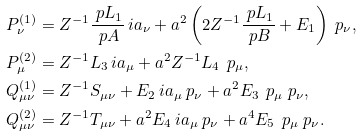Convert formula to latex. <formula><loc_0><loc_0><loc_500><loc_500>P ^ { ( 1 ) } _ { \nu } & = Z ^ { - 1 } \frac { \ p L _ { 1 } } { \ p A } \, i a _ { \nu } + a ^ { 2 } \left ( 2 Z ^ { - 1 } \frac { \ p L _ { 1 } } { \ p B } + E _ { 1 } \right ) \ p _ { \nu } , \\ P ^ { ( 2 ) } _ { \mu } & = Z ^ { - 1 } L _ { 3 } \, i a _ { \mu } + a ^ { 2 } Z ^ { - 1 } L _ { 4 } \, \ p _ { \mu } , \\ Q ^ { ( 1 ) } _ { \mu \nu } & = Z ^ { - 1 } S _ { \mu \nu } + E _ { 2 } \, i a _ { \mu } \ p _ { \nu } + a ^ { 2 } E _ { 3 } \, \ p _ { \mu } \ p _ { \nu } , \\ Q ^ { ( 2 ) } _ { \mu \nu } & = Z ^ { - 1 } T _ { \mu \nu } + a ^ { 2 } E _ { 4 } \, i a _ { \mu } \ p _ { \nu } + a ^ { 4 } E _ { 5 } \, \ p _ { \mu } \ p _ { \nu } .</formula> 